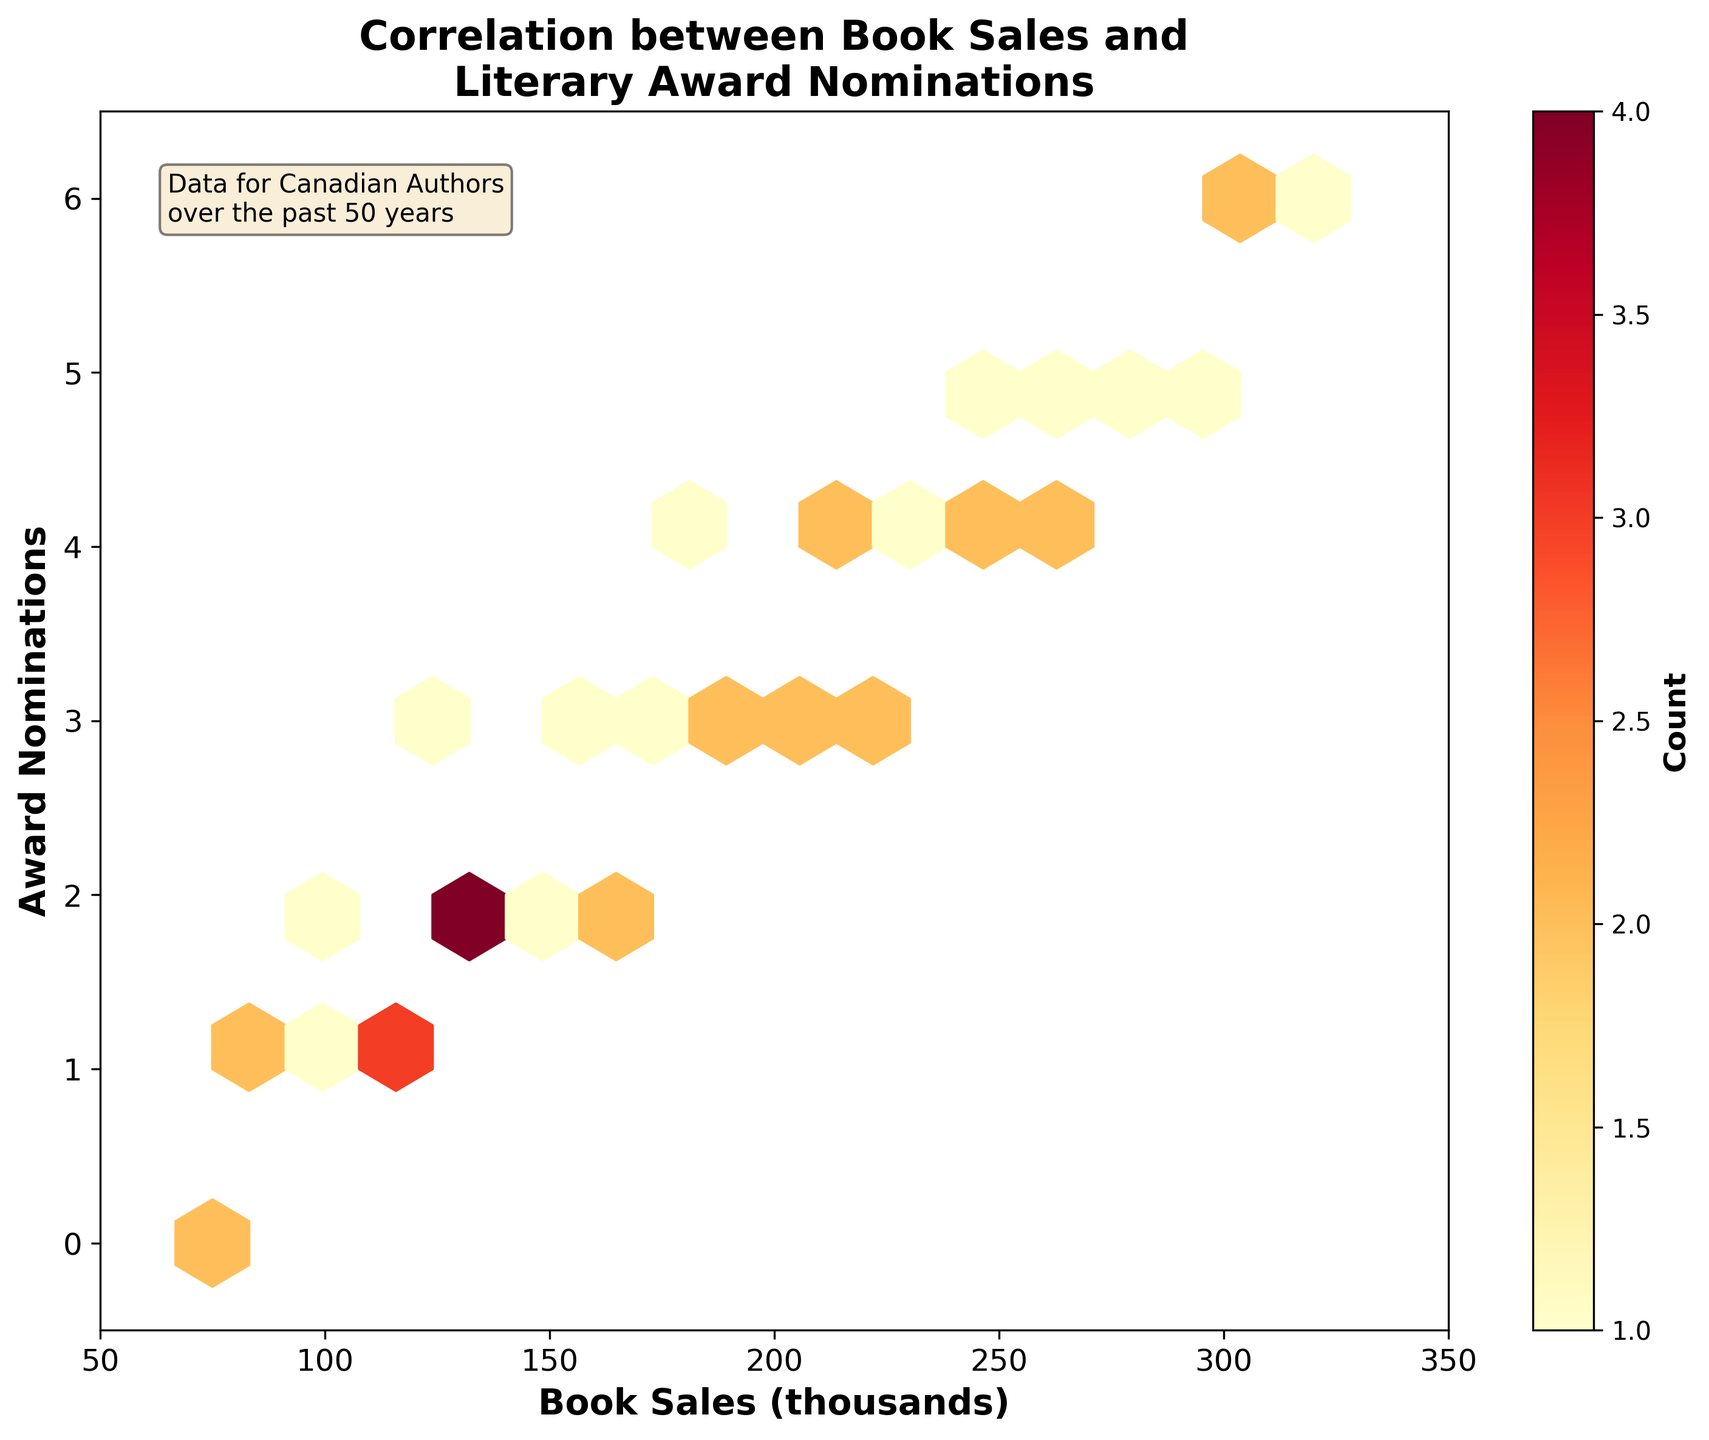What is the title of the figure? The title of a figure is usually given at the top and summarizes what the figure is about. In this case, the title reads "Correlation between Book Sales and Literary Award Nominations".
Answer: Correlation between Book Sales and Literary Award Nominations What are the x-axis and y-axis labels? The x-axis label tells us what is being measured along the horizontal axis, and the y-axis label tells us what is being measured along the vertical axis. Here, the x-axis is labeled "Book Sales (thousands)" and the y-axis is labeled "Award Nominations".
Answer: Book Sales (thousands) and Award Nominations What colors are used in the hexbin plot and what do they signify? The colors in the hexbin plot range from light yellow to deep red, indicating different counts within each hexbin. Lighter colors represent lower counts, and darker colors represent higher counts.
Answer: Light yellow to deep red represent count Which range of book sales has the highest density of award nominations? We look for the region with the darkest hexbin, which indicates the highest density. From the figure, the hexbin with the highest density is around the book sales range of 180 to 220 (thousands).
Answer: 180 to 220 (thousands) What is the count value indicated by the darkest color on the color bar? The darkest color on the color bar represents the highest count value. By examining the color bar on the right, we see that the darkest shade corresponds to a count of 5.
Answer: 5 How are award nominations distributed across books sales in the range of 50 to 100 (thousands)? By examining the figure, we see that in this range, the award nominations are quite sparse with fewer hexbin regions, mostly confined to 0 to 2 nominations.
Answer: Sparse, mostly 0 to 2 nominations Is there any correlation visible between book sales and award nominations? One can look for a trend, such as increasing award nominations with increasing book sales. The plot shows a tendency for higher nominations with higher book sales, suggesting a positive correlation.
Answer: Positive correlation Which book sales range shows the least award nominations? The light-colored hexbin regions indicate lower counts. Book sales in the range of 50 to 100 (thousands) show the least nominations, predominantly from 0 to 1.
Answer: 50 to 100 (thousands) Is there any outlier that stands out in terms of book sales and nominations? We check for isolated hexbins that appear away from the general cluster. There are no significant outliers as most hexbins fall within a concentrated range of data points.
Answer: No significant outliers 